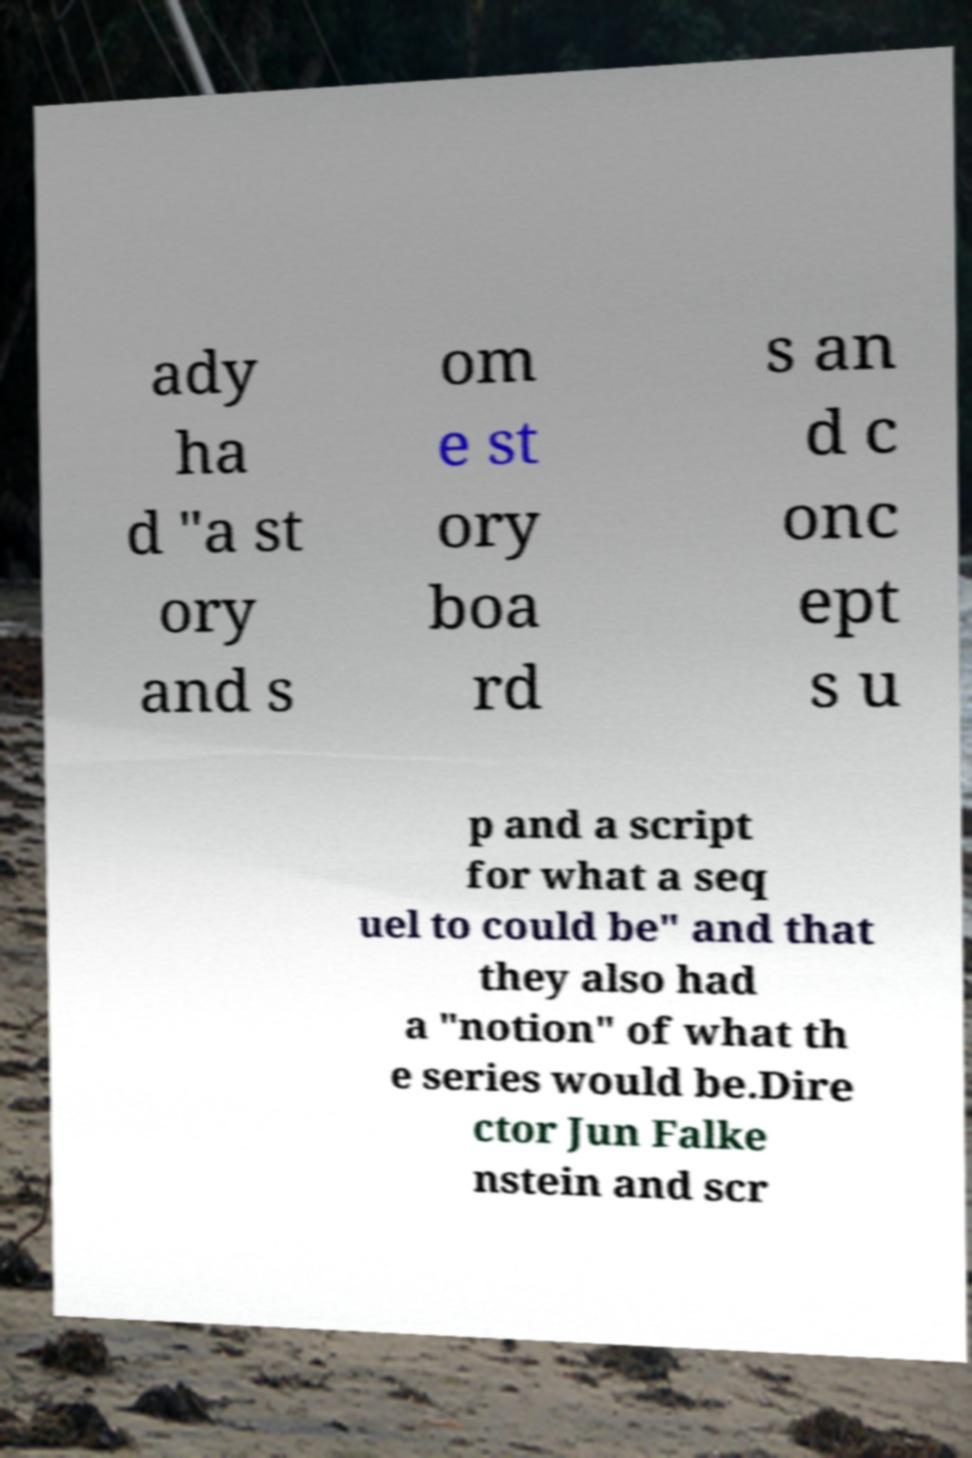I need the written content from this picture converted into text. Can you do that? ady ha d "a st ory and s om e st ory boa rd s an d c onc ept s u p and a script for what a seq uel to could be" and that they also had a "notion" of what th e series would be.Dire ctor Jun Falke nstein and scr 